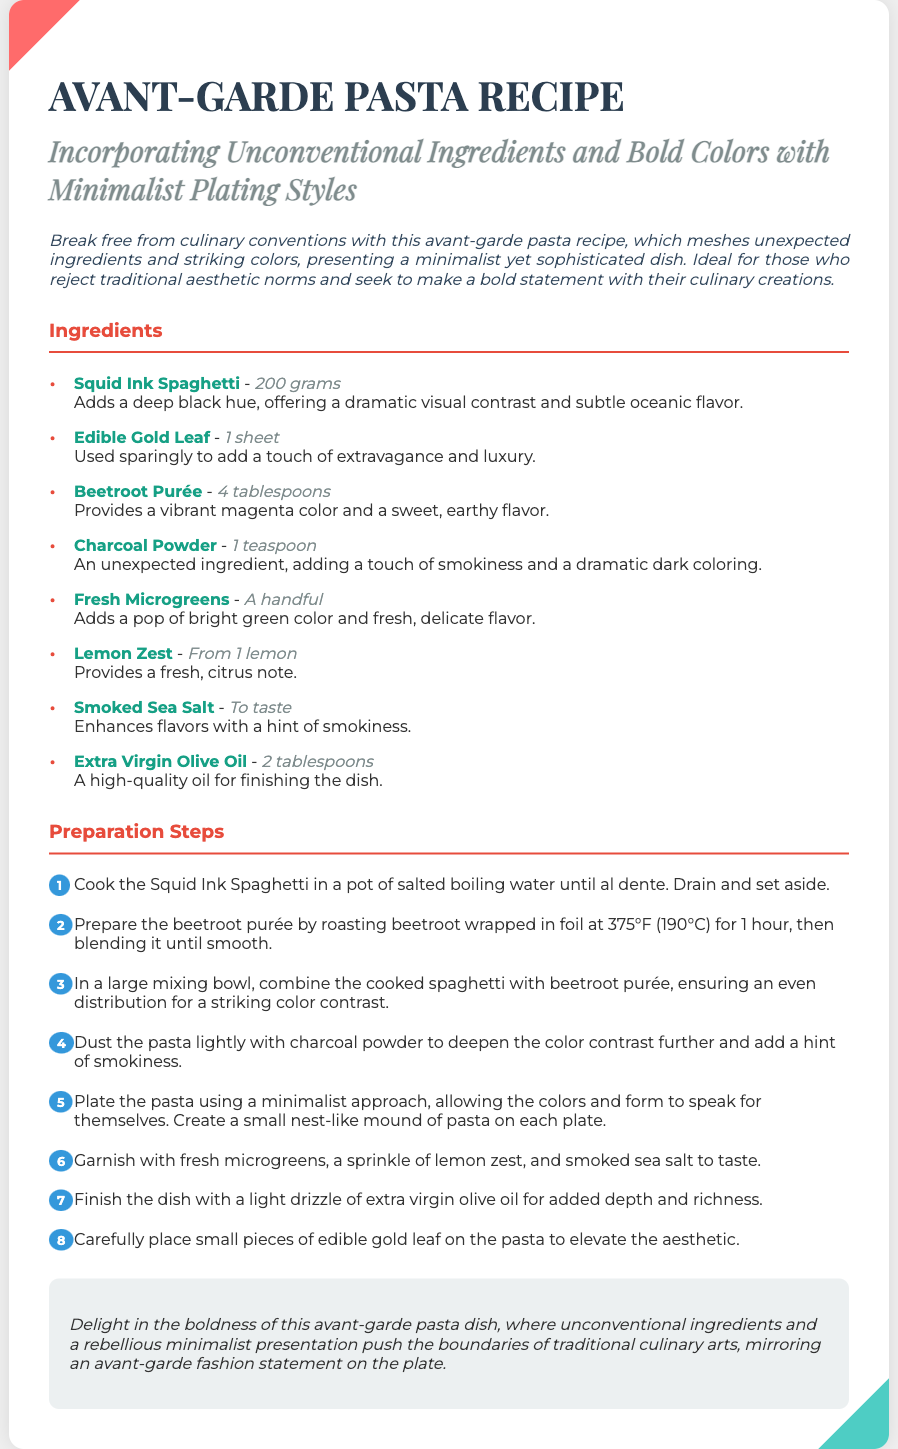What is the main color of the spaghetti used? The main color of the spaghetti is described as deep black due to the squid ink.
Answer: deep black How many tablespoons of beetroot purée are required? The recipe specifies that 4 tablespoons of beetroot purée are needed.
Answer: 4 tablespoons What is used for garnishing the pasta? The garnishing includes fresh microgreens, lemon zest, and smoked sea salt.
Answer: fresh microgreens, lemon zest, smoked sea salt What type of oil is used in this recipe? The recipe calls for extra virgin olive oil as the finishing oil.
Answer: extra virgin olive oil How is the beetroot prepared for the purée? The beetroot is roasted wrapped in foil at 375°F for 1 hour.
Answer: roasted wrapped in foil at 375°F for 1 hour What does the recipe suggest for plating the pasta? The recipe recommends a minimalist approach, creating a small nest-like mound of pasta on each plate.
Answer: a minimalist approach, small nest-like mound How does the recipe enhance the dish's visual appeal? The use of edible gold leaf adds a touch of extravagance and luxury to the dish.
Answer: edible gold leaf Which ingredient adds a hint of smokiness? The ingredient mentioned that adds a hint of smokiness is smoked sea salt.
Answer: smoked sea salt 